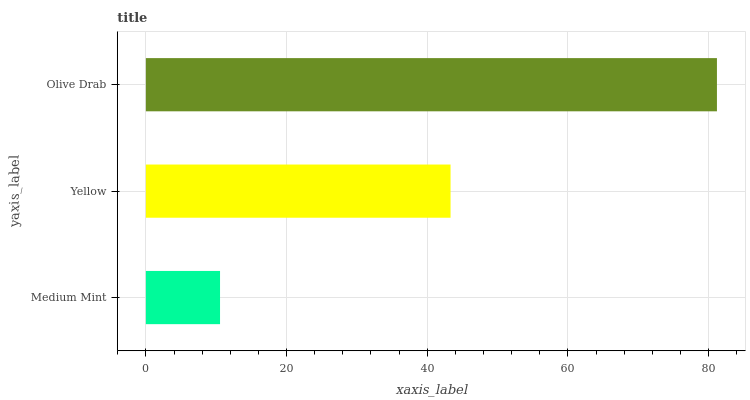Is Medium Mint the minimum?
Answer yes or no. Yes. Is Olive Drab the maximum?
Answer yes or no. Yes. Is Yellow the minimum?
Answer yes or no. No. Is Yellow the maximum?
Answer yes or no. No. Is Yellow greater than Medium Mint?
Answer yes or no. Yes. Is Medium Mint less than Yellow?
Answer yes or no. Yes. Is Medium Mint greater than Yellow?
Answer yes or no. No. Is Yellow less than Medium Mint?
Answer yes or no. No. Is Yellow the high median?
Answer yes or no. Yes. Is Yellow the low median?
Answer yes or no. Yes. Is Medium Mint the high median?
Answer yes or no. No. Is Medium Mint the low median?
Answer yes or no. No. 